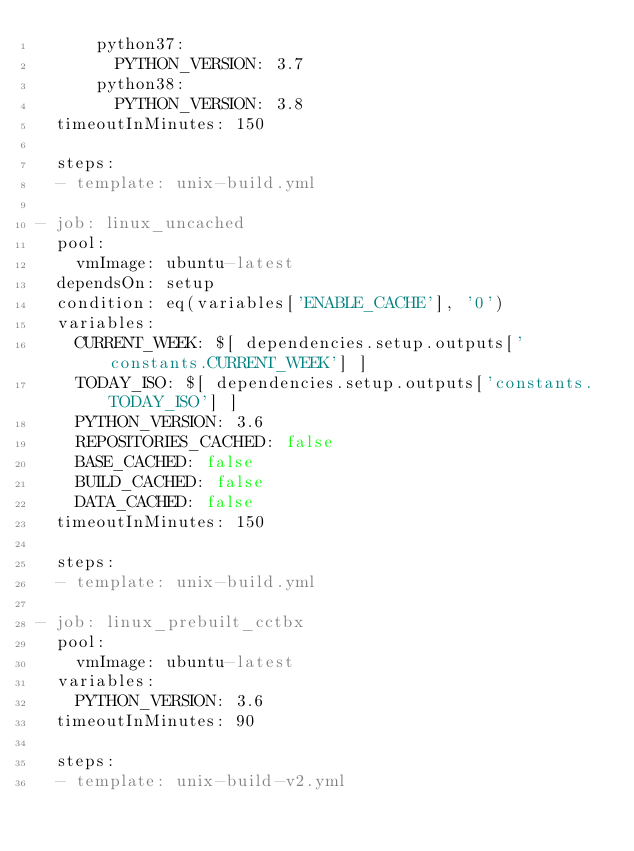Convert code to text. <code><loc_0><loc_0><loc_500><loc_500><_YAML_>      python37:
        PYTHON_VERSION: 3.7
      python38:
        PYTHON_VERSION: 3.8
  timeoutInMinutes: 150

  steps:
  - template: unix-build.yml

- job: linux_uncached
  pool:
    vmImage: ubuntu-latest
  dependsOn: setup
  condition: eq(variables['ENABLE_CACHE'], '0')
  variables:
    CURRENT_WEEK: $[ dependencies.setup.outputs['constants.CURRENT_WEEK'] ]
    TODAY_ISO: $[ dependencies.setup.outputs['constants.TODAY_ISO'] ]
    PYTHON_VERSION: 3.6
    REPOSITORIES_CACHED: false
    BASE_CACHED: false
    BUILD_CACHED: false
    DATA_CACHED: false
  timeoutInMinutes: 150

  steps:
  - template: unix-build.yml

- job: linux_prebuilt_cctbx
  pool:
    vmImage: ubuntu-latest
  variables:
    PYTHON_VERSION: 3.6
  timeoutInMinutes: 90

  steps:
  - template: unix-build-v2.yml
</code> 